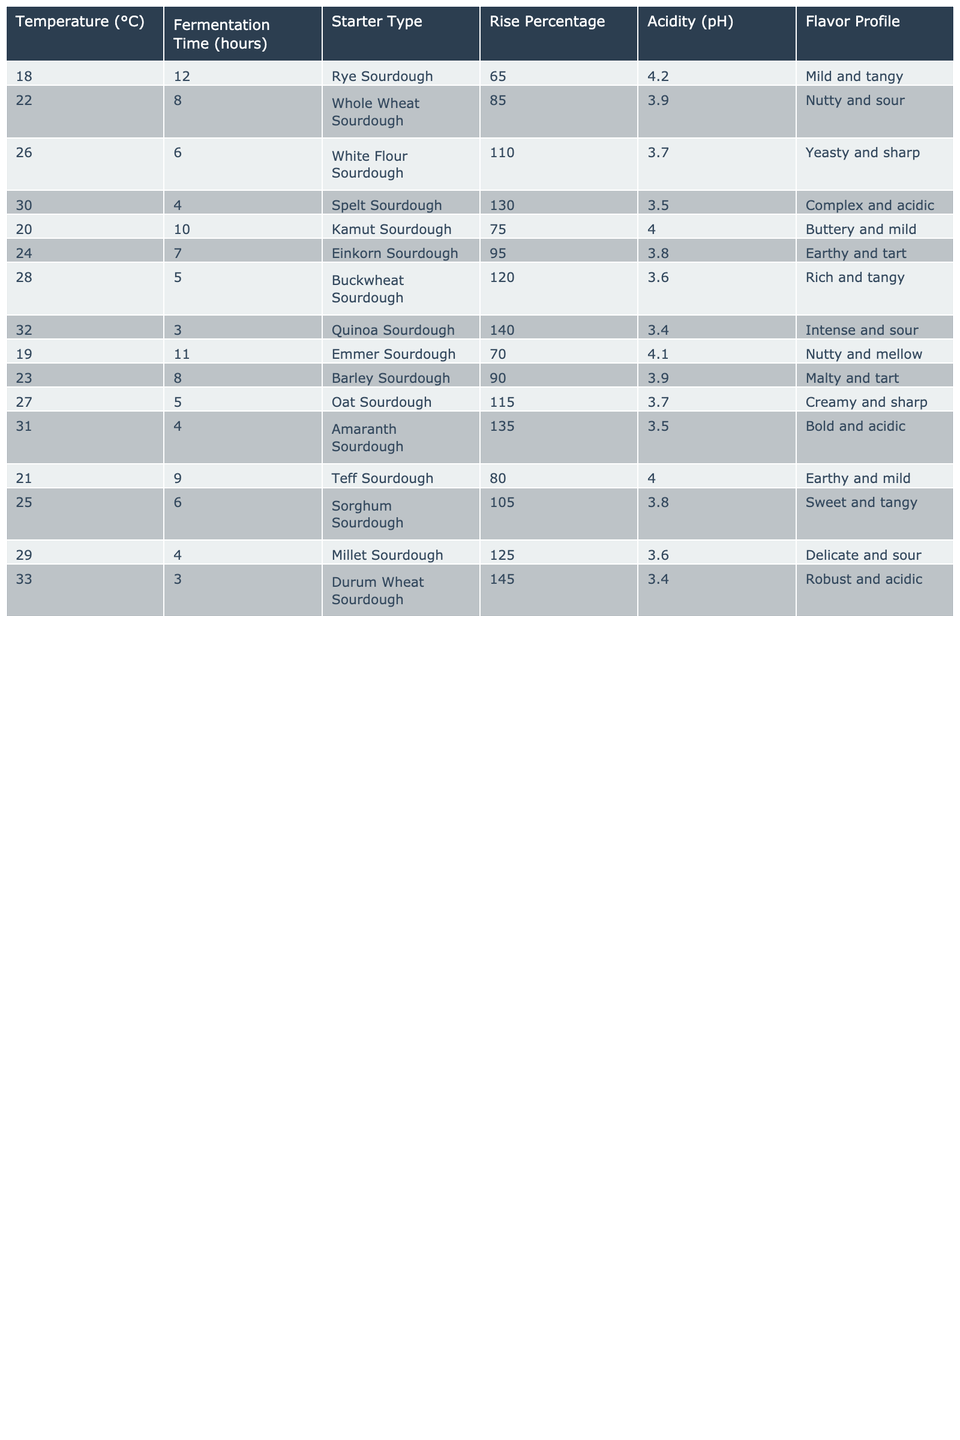What is the rise percentage for the White Flour Sourdough? The table shows that the rise percentage for White Flour Sourdough is listed in its corresponding row under the "Rise Percentage" column. Looking directly at that row, the value is 110.
Answer: 110 Which sourdough starter type had the highest acidity (pH)? To find the highest acidity, we need to look at the "Acidity (pH)" column, find the maximum value, and see which starter it corresponds to. The highest pH value in the table is 4.2, corresponding to the Rye Sourdough.
Answer: Rye Sourdough What is the average fermentation time for starters with a temperature above 25°C? To find the average fermentation time for starters above 25°C, we need to identify the relevant rows (26, 30, 28, 32, 29, 33) which have fermentation times of 6, 4, 5, 3, 4, and 3 hours respectively. The sum of these times is 6 + 4 + 5 + 3 + 4 + 3 = 25 hours, and there are 6 data points, so the average is 25/6 ≈ 4.17 hours.
Answer: 4.17 Is it true that all starters fermented at 32°C had a rise percentage greater than 130? Checking the table, we see that the starter fermented at 32°C (Quinoa Sourdough) has a rise percentage of 140. This is greater than 130. Therefore, the statement is true without needing to check other entries.
Answer: True Which starter type had the lowest fermentation time and what is the rise percentage for that starter? The lowest fermentation time can be found by scanning the "Fermentation Time (hours)" column, where the minimum value is 3 hours corresponding to both Quinoa Sourdough and Durum Wheat Sourdough. Notably, the rise percentage for Quinoa Sourdough is 140, and for Durum Wheat Sourdough, it's 145. The question specifically only asks for one, thus we can choose Quinoa Sourdough for this answer.
Answer: Quinoa Sourdough has a rise percentage of 140 How does the acidity of Rye Sourdough compare to Whole Wheat Sourdough? We refer to the table to retrieve the acidity values for Rye Sourdough (4.2) and Whole Wheat Sourdough (3.9). Since 4.2 is greater than 3.9, we can conclude that Rye Sourdough is less acidic than Whole Wheat Sourdough.
Answer: Rye Sourdough is less acidic What is the flavor profile of the starter type that shows the fastest fermentation time? The fastest fermentation time listed is 3 hours, which corresponds to the Quinoa Sourdough. By looking at the "Flavor Profile" column in the same row, we find that its flavor profile is "Intense and sour."
Answer: Intense and sour Which sourdough types have a rise percentage lower than 80? From the table, we need to scan the "Rise Percentage" column to find values lower than 80. Those that fit include Rye Sourdough (65) and Emmer Sourdough (70). Therefore, these are the identified starters.
Answer: Rye Sourdough and Emmer Sourdough What is the trend in rise percentage as the temperature increases from 18°C to 33°C? By examining the "Rise Percentage" column alongside the temperature, we can see the numbers generally increase as the temperature rises. The initial rise starts lower at 65 at 18°C and grows higher up to 145 at 33°C, indicating a consistent upward trend overall.
Answer: The trend shows an upward increase 